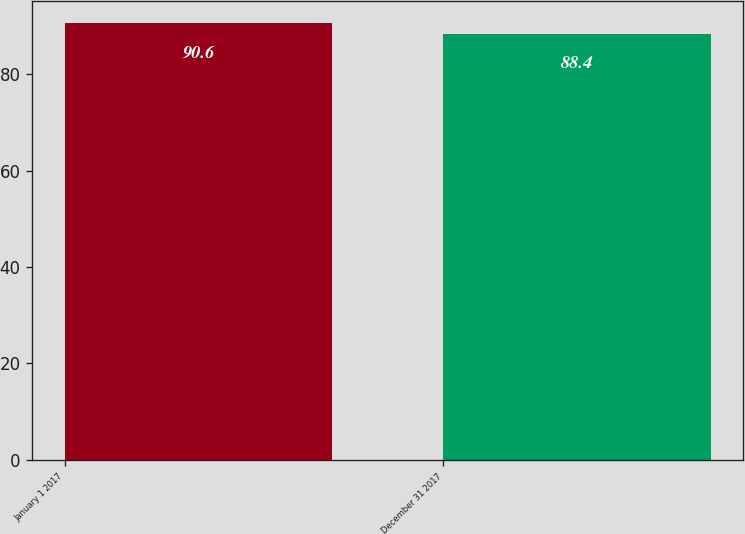<chart> <loc_0><loc_0><loc_500><loc_500><bar_chart><fcel>January 1 2017<fcel>December 31 2017<nl><fcel>90.6<fcel>88.4<nl></chart> 